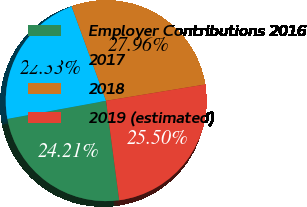Convert chart to OTSL. <chart><loc_0><loc_0><loc_500><loc_500><pie_chart><fcel>Employer Contributions 2016<fcel>2017<fcel>2018<fcel>2019 (estimated)<nl><fcel>24.21%<fcel>22.33%<fcel>27.96%<fcel>25.5%<nl></chart> 